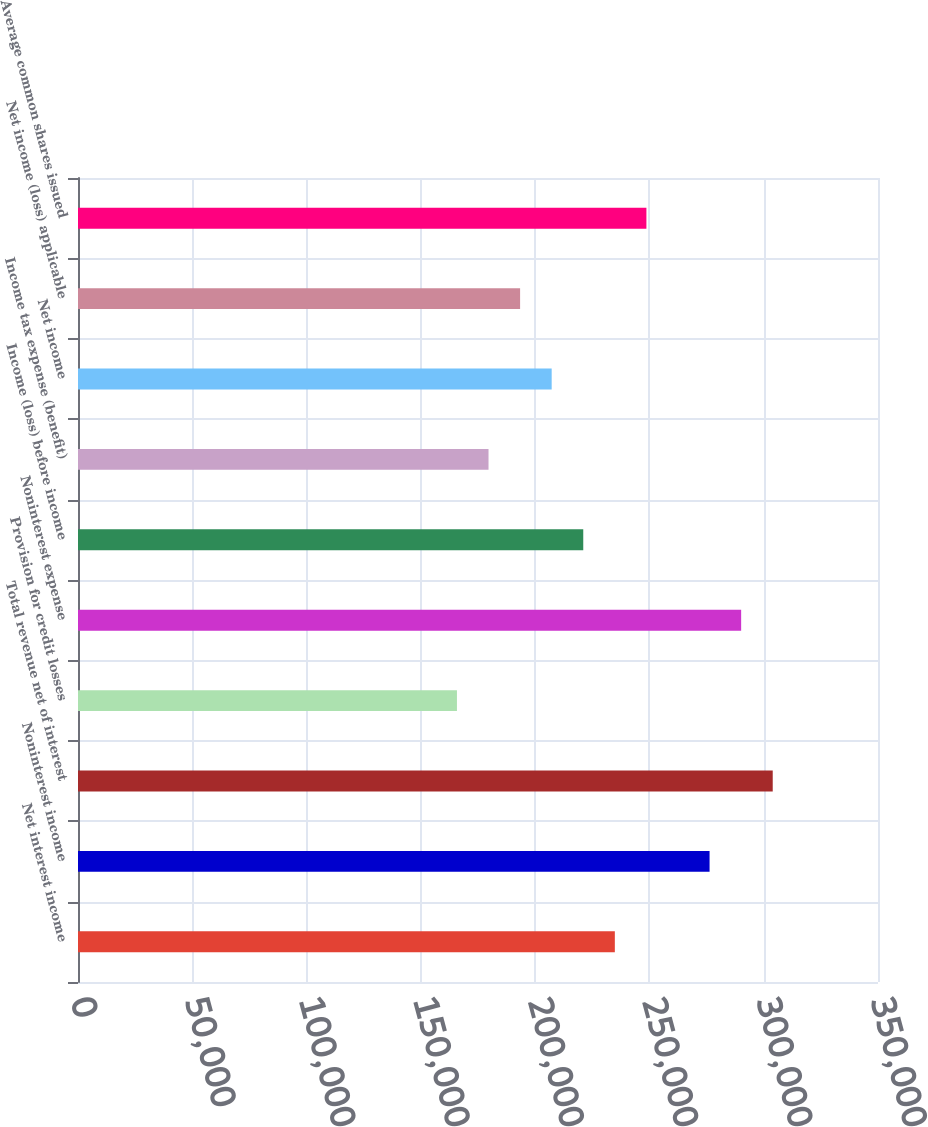<chart> <loc_0><loc_0><loc_500><loc_500><bar_chart><fcel>Net interest income<fcel>Noninterest income<fcel>Total revenue net of interest<fcel>Provision for credit losses<fcel>Noninterest expense<fcel>Income (loss) before income<fcel>Income tax expense (benefit)<fcel>Net income<fcel>Net income (loss) applicable<fcel>Average common shares issued<nl><fcel>234865<fcel>276312<fcel>303943<fcel>165787<fcel>290128<fcel>221050<fcel>179603<fcel>207234<fcel>193418<fcel>248681<nl></chart> 